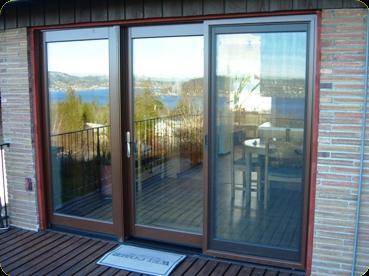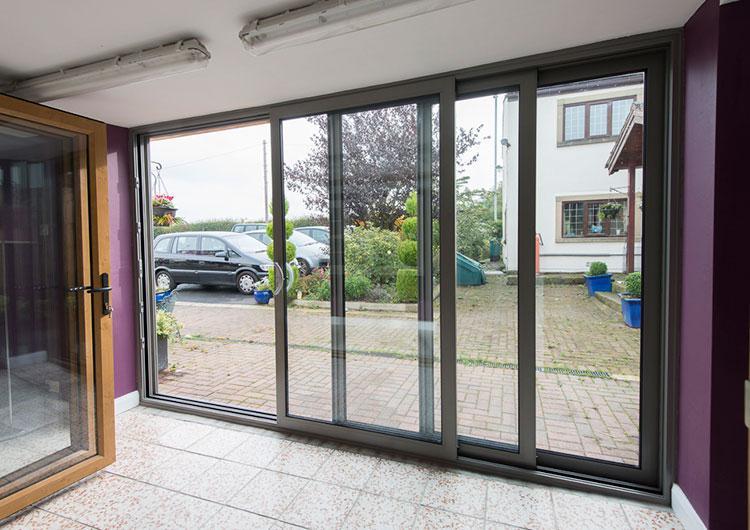The first image is the image on the left, the second image is the image on the right. Considering the images on both sides, is "A sliding glass door unit has three door-shaped sections and no door is open." valid? Answer yes or no. Yes. 